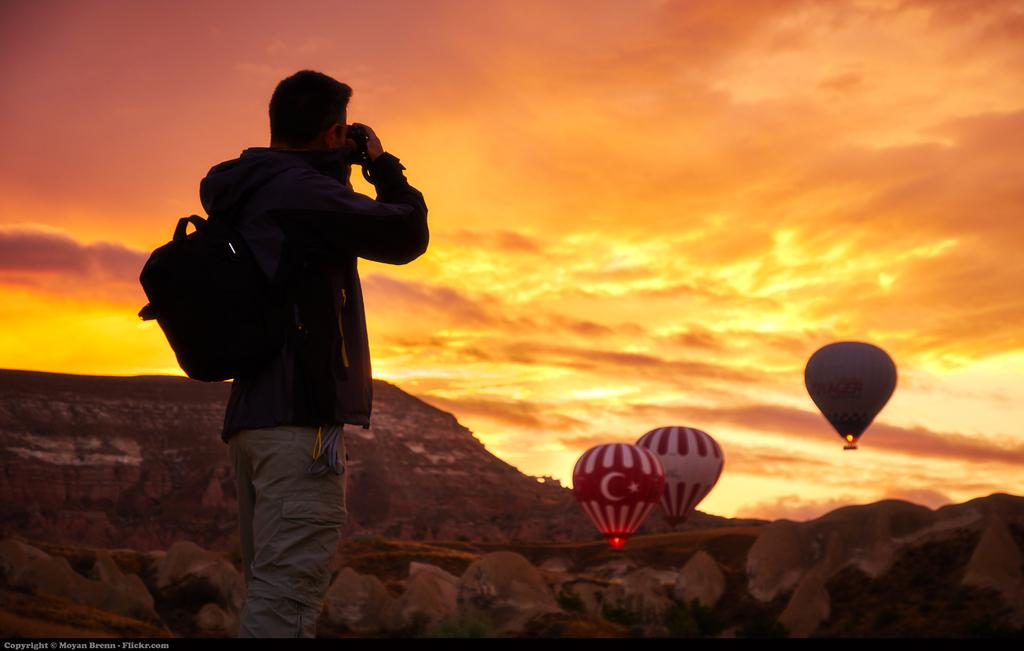What is the man in the image holding? The man is holding a backpack and a camera. What is the man doing with the camera? The man is clicking a picture. How many parachutes are visible in the image? There are three parachutes in the image. What type of terrain is visible in the image? There are rocks and a mountain in the image. What part of the natural environment is visible in the image? The sky is visible in the image. What type of business is being conducted in the image? There is no indication of any business being conducted in the image; it primarily features a man taking a picture with a camera. 